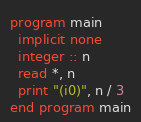Convert code to text. <code><loc_0><loc_0><loc_500><loc_500><_FORTRAN_>program main
  implicit none
  integer :: n
  read *, n
  print "(i0)", n / 3
end program main
</code> 